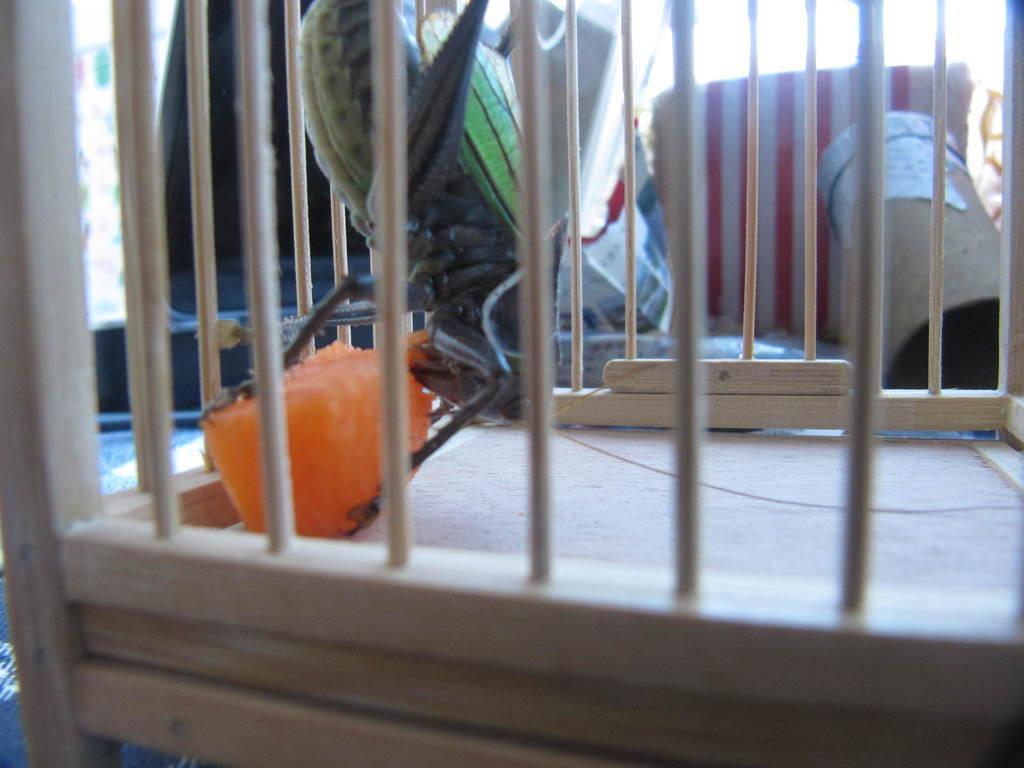Could you give a brief overview of what you see in this image? In this image, we can see a cage and inside the cage, there is an insect and some food item. In the background, there are some boxes and some clothes. 